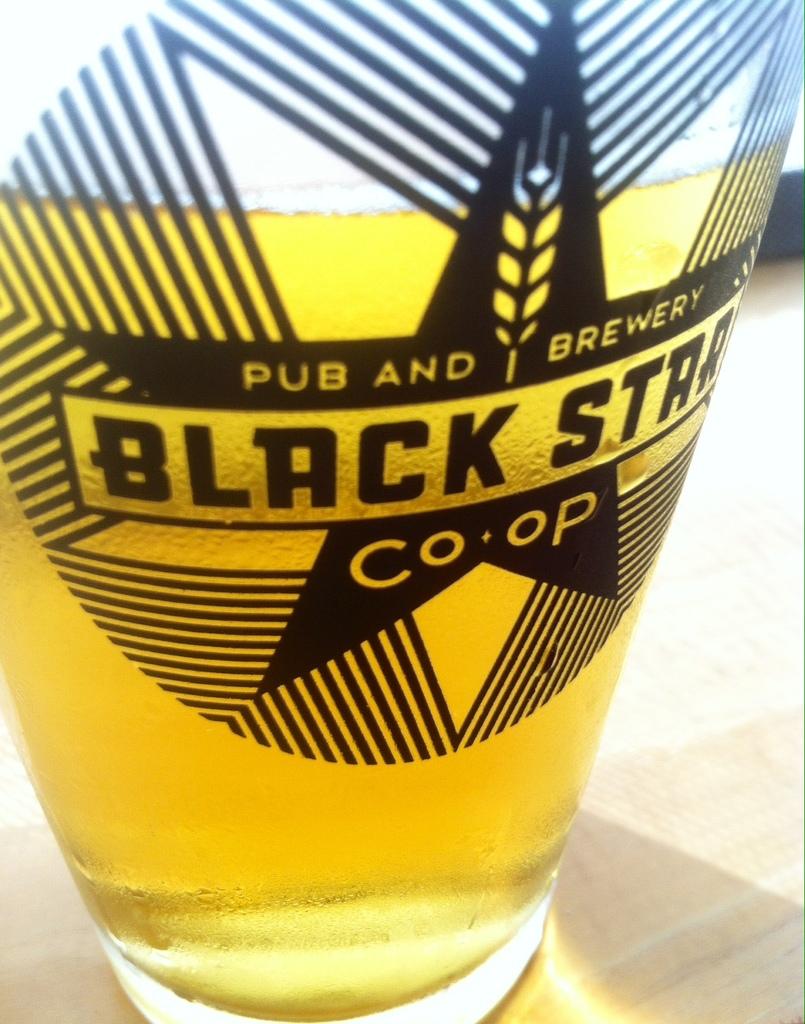What is the name of the brewery?
Keep it short and to the point. Black star. What is the first word written inthe top left corner of the star?
Make the answer very short. Pub. 